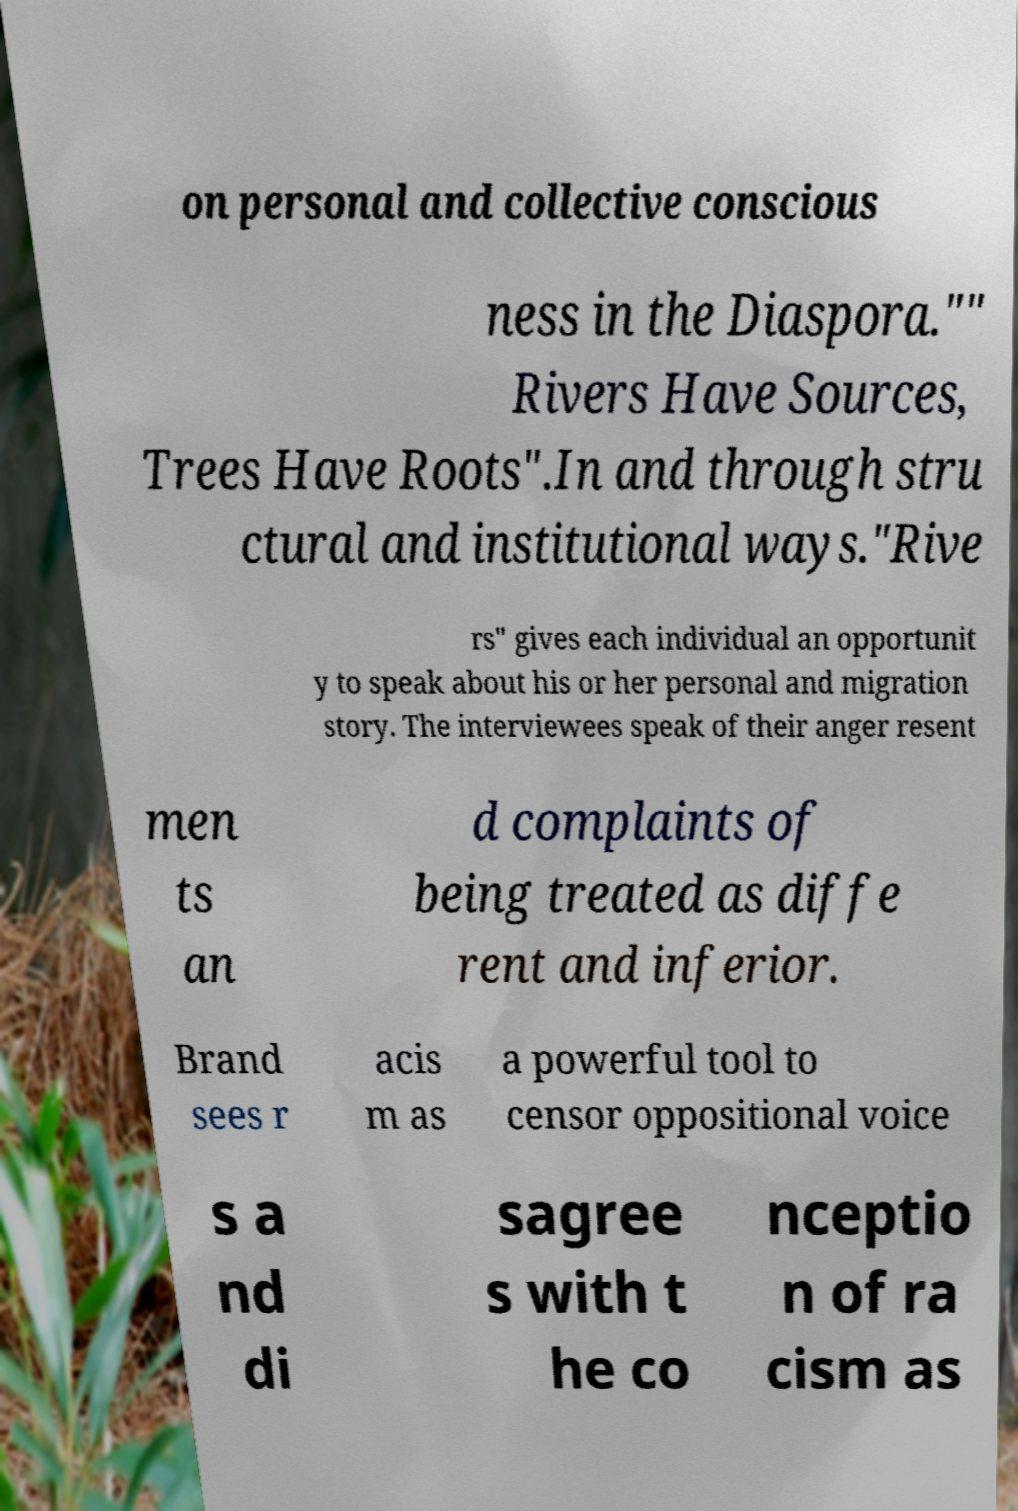For documentation purposes, I need the text within this image transcribed. Could you provide that? on personal and collective conscious ness in the Diaspora."" Rivers Have Sources, Trees Have Roots".In and through stru ctural and institutional ways."Rive rs" gives each individual an opportunit y to speak about his or her personal and migration story. The interviewees speak of their anger resent men ts an d complaints of being treated as diffe rent and inferior. Brand sees r acis m as a powerful tool to censor oppositional voice s a nd di sagree s with t he co nceptio n of ra cism as 